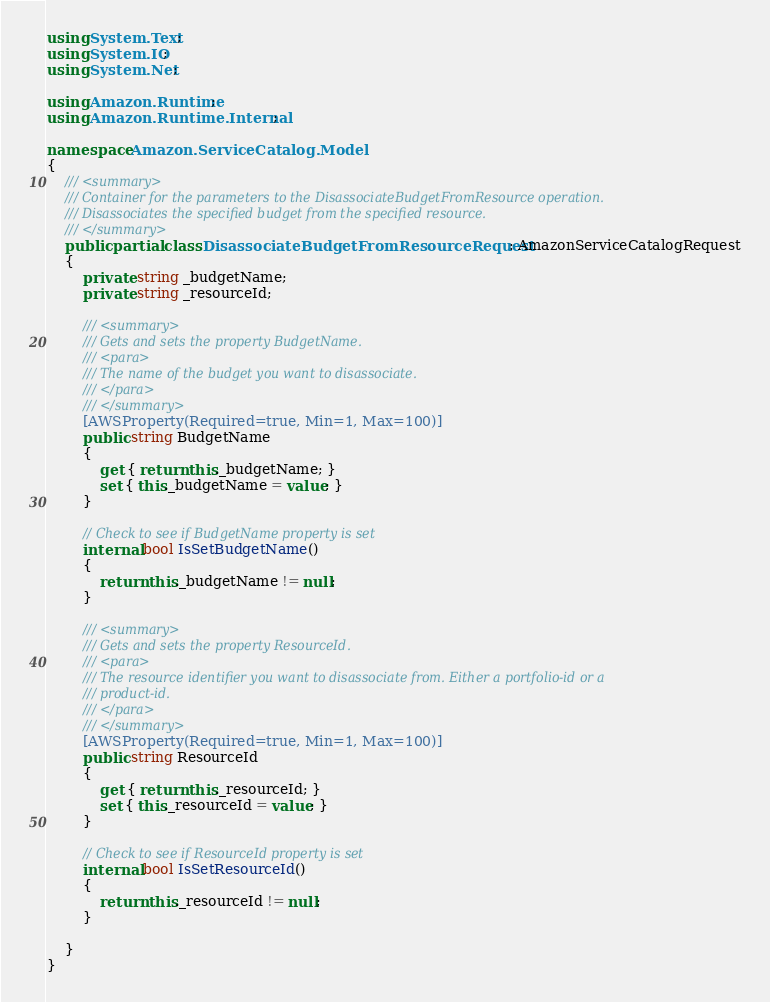Convert code to text. <code><loc_0><loc_0><loc_500><loc_500><_C#_>using System.Text;
using System.IO;
using System.Net;

using Amazon.Runtime;
using Amazon.Runtime.Internal;

namespace Amazon.ServiceCatalog.Model
{
    /// <summary>
    /// Container for the parameters to the DisassociateBudgetFromResource operation.
    /// Disassociates the specified budget from the specified resource.
    /// </summary>
    public partial class DisassociateBudgetFromResourceRequest : AmazonServiceCatalogRequest
    {
        private string _budgetName;
        private string _resourceId;

        /// <summary>
        /// Gets and sets the property BudgetName. 
        /// <para>
        /// The name of the budget you want to disassociate.
        /// </para>
        /// </summary>
        [AWSProperty(Required=true, Min=1, Max=100)]
        public string BudgetName
        {
            get { return this._budgetName; }
            set { this._budgetName = value; }
        }

        // Check to see if BudgetName property is set
        internal bool IsSetBudgetName()
        {
            return this._budgetName != null;
        }

        /// <summary>
        /// Gets and sets the property ResourceId. 
        /// <para>
        /// The resource identifier you want to disassociate from. Either a portfolio-id or a
        /// product-id.
        /// </para>
        /// </summary>
        [AWSProperty(Required=true, Min=1, Max=100)]
        public string ResourceId
        {
            get { return this._resourceId; }
            set { this._resourceId = value; }
        }

        // Check to see if ResourceId property is set
        internal bool IsSetResourceId()
        {
            return this._resourceId != null;
        }

    }
}</code> 